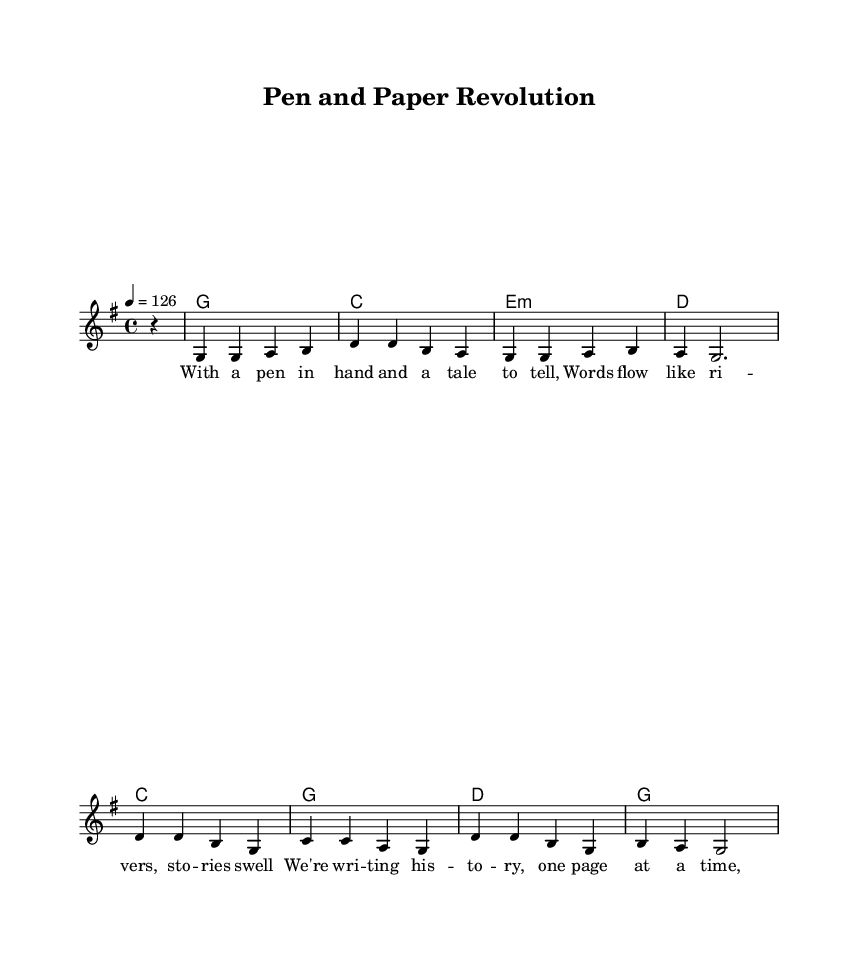What is the key signature of this music? The key signature is G major, which has one sharp (F#). It is indicated at the beginning of the staff in the sheet music.
Answer: G major What is the time signature of this music? The time signature is 4/4, which means there are four beats in each measure and the quarter note gets one beat. This is typically found at the beginning of the score.
Answer: 4/4 What is the tempo marking for this piece? The tempo marking is indicated as '4 = 126', which means the quarter note should be played at a speed of 126 beats per minute. This is typically placed at the start and gives a guideline for the pace of the music.
Answer: 126 How many measures are in the melody section? The melody section, as indicated by the notation, contains 8 measures. Each measure can be counted through the rhythmic values presented, and they are separated by vertical lines in the sheet music.
Answer: 8 What thematic element does the chorus emphasize? The chorus emphasizes the theme of writing history and the revolution of storytelling with the use of pen and paper. This can be inferred from the lyrics placed in the chorus section, which focus on the act of writing.
Answer: Writing history What type of chords are used in this song's harmony? The harmonies used in this song consist of major and minor chords, specifically G major, C major, E minor, and D major. This is shown in the chord names present above the staff.
Answer: Major and minor chords How do the lyrics reflect the Country Rock genre? The lyrics reflect storytelling and a personal journey, important themes in Country Rock music. This can be deduced from the lyrical content that celebrates the art of storytelling, a hallmark of the genre.
Answer: Storytelling themes 